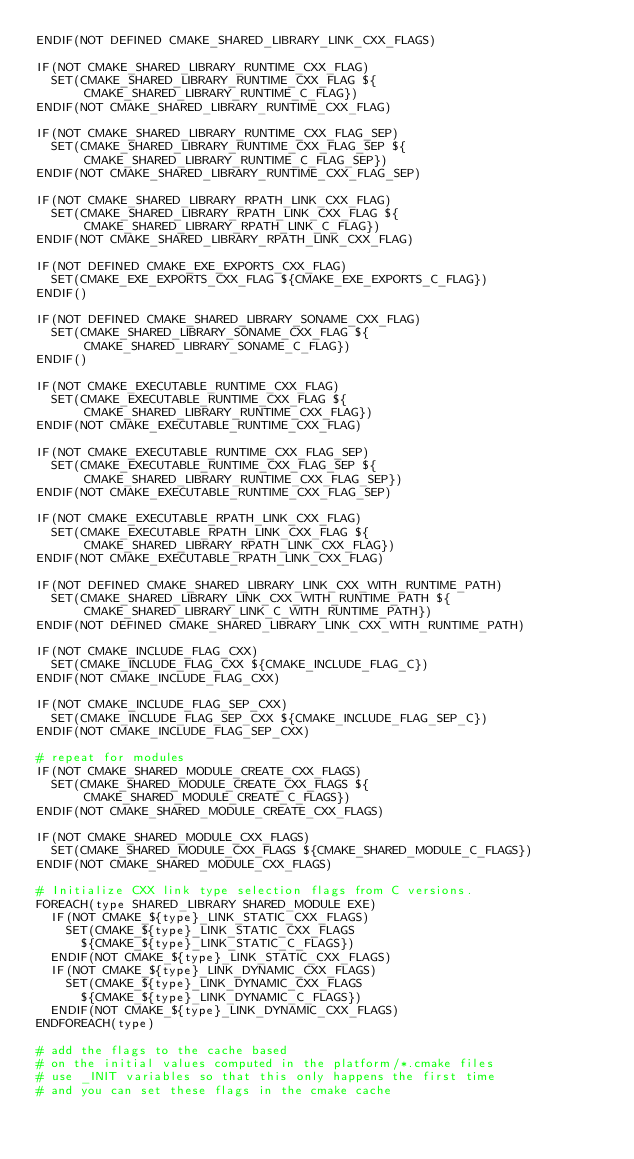Convert code to text. <code><loc_0><loc_0><loc_500><loc_500><_CMake_>ENDIF(NOT DEFINED CMAKE_SHARED_LIBRARY_LINK_CXX_FLAGS)

IF(NOT CMAKE_SHARED_LIBRARY_RUNTIME_CXX_FLAG)
  SET(CMAKE_SHARED_LIBRARY_RUNTIME_CXX_FLAG ${CMAKE_SHARED_LIBRARY_RUNTIME_C_FLAG}) 
ENDIF(NOT CMAKE_SHARED_LIBRARY_RUNTIME_CXX_FLAG)

IF(NOT CMAKE_SHARED_LIBRARY_RUNTIME_CXX_FLAG_SEP)
  SET(CMAKE_SHARED_LIBRARY_RUNTIME_CXX_FLAG_SEP ${CMAKE_SHARED_LIBRARY_RUNTIME_C_FLAG_SEP})
ENDIF(NOT CMAKE_SHARED_LIBRARY_RUNTIME_CXX_FLAG_SEP)

IF(NOT CMAKE_SHARED_LIBRARY_RPATH_LINK_CXX_FLAG)
  SET(CMAKE_SHARED_LIBRARY_RPATH_LINK_CXX_FLAG ${CMAKE_SHARED_LIBRARY_RPATH_LINK_C_FLAG})
ENDIF(NOT CMAKE_SHARED_LIBRARY_RPATH_LINK_CXX_FLAG)

IF(NOT DEFINED CMAKE_EXE_EXPORTS_CXX_FLAG)
  SET(CMAKE_EXE_EXPORTS_CXX_FLAG ${CMAKE_EXE_EXPORTS_C_FLAG})
ENDIF()

IF(NOT DEFINED CMAKE_SHARED_LIBRARY_SONAME_CXX_FLAG)
  SET(CMAKE_SHARED_LIBRARY_SONAME_CXX_FLAG ${CMAKE_SHARED_LIBRARY_SONAME_C_FLAG})
ENDIF()

IF(NOT CMAKE_EXECUTABLE_RUNTIME_CXX_FLAG)
  SET(CMAKE_EXECUTABLE_RUNTIME_CXX_FLAG ${CMAKE_SHARED_LIBRARY_RUNTIME_CXX_FLAG})
ENDIF(NOT CMAKE_EXECUTABLE_RUNTIME_CXX_FLAG)

IF(NOT CMAKE_EXECUTABLE_RUNTIME_CXX_FLAG_SEP)
  SET(CMAKE_EXECUTABLE_RUNTIME_CXX_FLAG_SEP ${CMAKE_SHARED_LIBRARY_RUNTIME_CXX_FLAG_SEP})
ENDIF(NOT CMAKE_EXECUTABLE_RUNTIME_CXX_FLAG_SEP)

IF(NOT CMAKE_EXECUTABLE_RPATH_LINK_CXX_FLAG)
  SET(CMAKE_EXECUTABLE_RPATH_LINK_CXX_FLAG ${CMAKE_SHARED_LIBRARY_RPATH_LINK_CXX_FLAG})
ENDIF(NOT CMAKE_EXECUTABLE_RPATH_LINK_CXX_FLAG)

IF(NOT DEFINED CMAKE_SHARED_LIBRARY_LINK_CXX_WITH_RUNTIME_PATH)
  SET(CMAKE_SHARED_LIBRARY_LINK_CXX_WITH_RUNTIME_PATH ${CMAKE_SHARED_LIBRARY_LINK_C_WITH_RUNTIME_PATH})
ENDIF(NOT DEFINED CMAKE_SHARED_LIBRARY_LINK_CXX_WITH_RUNTIME_PATH)

IF(NOT CMAKE_INCLUDE_FLAG_CXX)
  SET(CMAKE_INCLUDE_FLAG_CXX ${CMAKE_INCLUDE_FLAG_C})
ENDIF(NOT CMAKE_INCLUDE_FLAG_CXX)

IF(NOT CMAKE_INCLUDE_FLAG_SEP_CXX)
  SET(CMAKE_INCLUDE_FLAG_SEP_CXX ${CMAKE_INCLUDE_FLAG_SEP_C})
ENDIF(NOT CMAKE_INCLUDE_FLAG_SEP_CXX)

# repeat for modules
IF(NOT CMAKE_SHARED_MODULE_CREATE_CXX_FLAGS)
  SET(CMAKE_SHARED_MODULE_CREATE_CXX_FLAGS ${CMAKE_SHARED_MODULE_CREATE_C_FLAGS})
ENDIF(NOT CMAKE_SHARED_MODULE_CREATE_CXX_FLAGS)

IF(NOT CMAKE_SHARED_MODULE_CXX_FLAGS)
  SET(CMAKE_SHARED_MODULE_CXX_FLAGS ${CMAKE_SHARED_MODULE_C_FLAGS})
ENDIF(NOT CMAKE_SHARED_MODULE_CXX_FLAGS)

# Initialize CXX link type selection flags from C versions.
FOREACH(type SHARED_LIBRARY SHARED_MODULE EXE)
  IF(NOT CMAKE_${type}_LINK_STATIC_CXX_FLAGS)
    SET(CMAKE_${type}_LINK_STATIC_CXX_FLAGS
      ${CMAKE_${type}_LINK_STATIC_C_FLAGS})
  ENDIF(NOT CMAKE_${type}_LINK_STATIC_CXX_FLAGS)
  IF(NOT CMAKE_${type}_LINK_DYNAMIC_CXX_FLAGS)
    SET(CMAKE_${type}_LINK_DYNAMIC_CXX_FLAGS
      ${CMAKE_${type}_LINK_DYNAMIC_C_FLAGS})
  ENDIF(NOT CMAKE_${type}_LINK_DYNAMIC_CXX_FLAGS)
ENDFOREACH(type)

# add the flags to the cache based
# on the initial values computed in the platform/*.cmake files
# use _INIT variables so that this only happens the first time
# and you can set these flags in the cmake cache</code> 